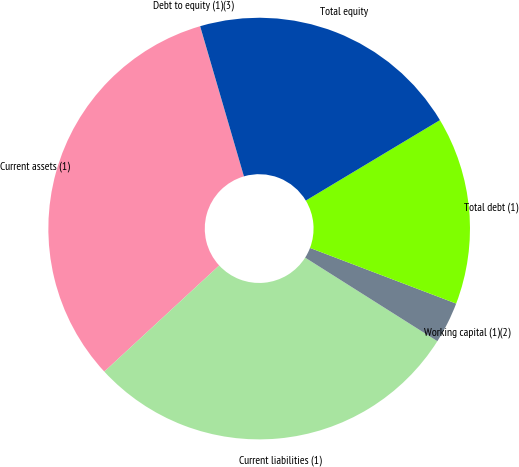<chart> <loc_0><loc_0><loc_500><loc_500><pie_chart><fcel>Current assets (1)<fcel>Current liabilities (1)<fcel>Working capital (1)(2)<fcel>Total debt (1)<fcel>Total equity<fcel>Debt to equity (1)(3)<nl><fcel>32.34%<fcel>29.16%<fcel>3.18%<fcel>14.39%<fcel>20.92%<fcel>0.01%<nl></chart> 